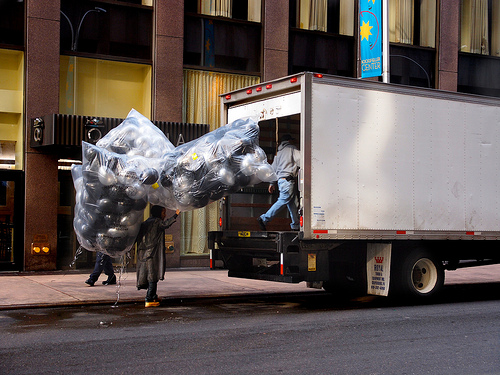<image>
Is there a balloons next to the person? Yes. The balloons is positioned adjacent to the person, located nearby in the same general area. 